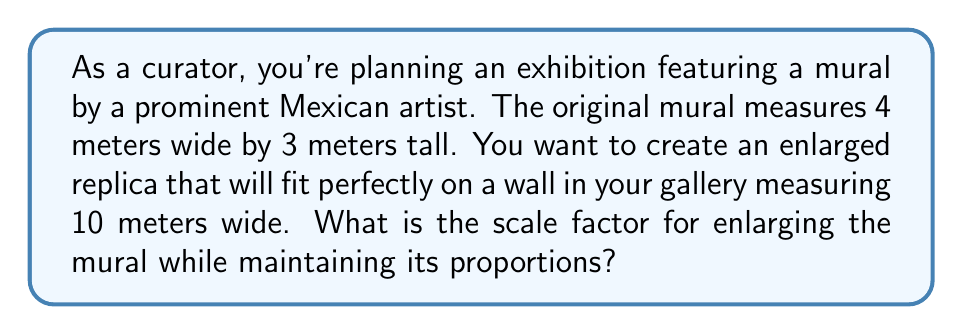Teach me how to tackle this problem. To solve this problem, we need to determine the scale factor that will enlarge the mural proportionally to fit the new width. Let's approach this step-by-step:

1) First, let's define our scale factor as $s$. This factor will be applied to both the width and height of the original mural to maintain its proportions.

2) We know that the new width should be 10 meters. We can express this as an equation:

   $4s = 10$

   Where 4 is the original width and 10 is the new width.

3) To solve for $s$, we divide both sides by 4:

   $s = \frac{10}{4} = \frac{5}{2} = 2.5$

4) We can verify that this scale factor works for the height as well:

   Original height: 3 meters
   New height: $3 * 2.5 = 7.5$ meters

5) Let's check if the new dimensions maintain the original proportions:

   Original ratio: $\frac{4}{3} \approx 1.33$
   New ratio: $\frac{10}{7.5} \approx 1.33$

   The ratios are the same, confirming that the proportions are maintained.

Therefore, the scale factor for enlarging the mural while maintaining its proportions is 2.5.
Answer: The scale factor is 2.5 